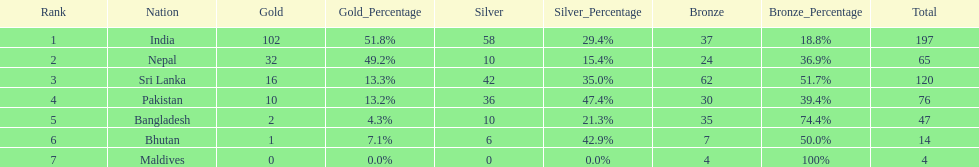Name the first country on the table? India. 